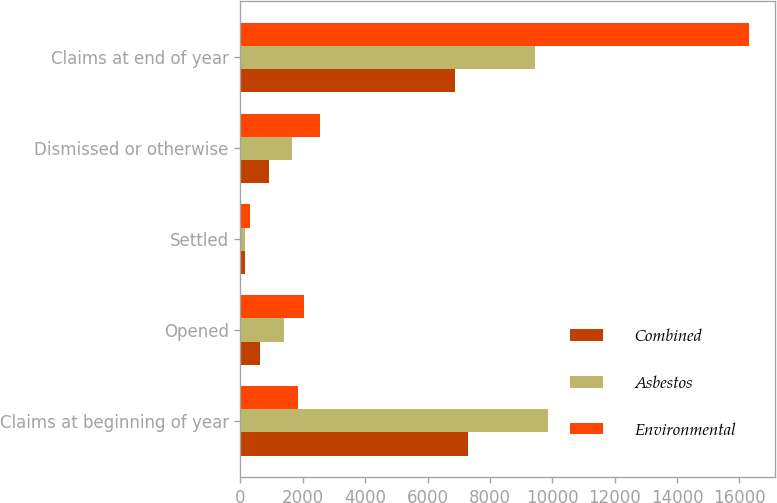<chart> <loc_0><loc_0><loc_500><loc_500><stacked_bar_chart><ecel><fcel>Claims at beginning of year<fcel>Opened<fcel>Settled<fcel>Dismissed or otherwise<fcel>Claims at end of year<nl><fcel>Combined<fcel>7293<fcel>643<fcel>150<fcel>908<fcel>6878<nl><fcel>Asbestos<fcel>9873<fcel>1383<fcel>155<fcel>1659<fcel>9442<nl><fcel>Environmental<fcel>1842.5<fcel>2026<fcel>305<fcel>2567<fcel>16320<nl></chart> 